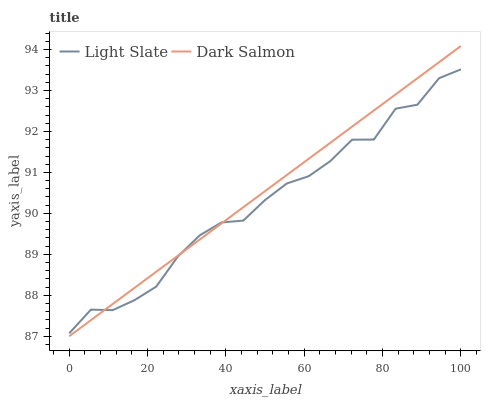Does Dark Salmon have the minimum area under the curve?
Answer yes or no. No. Is Dark Salmon the roughest?
Answer yes or no. No. 